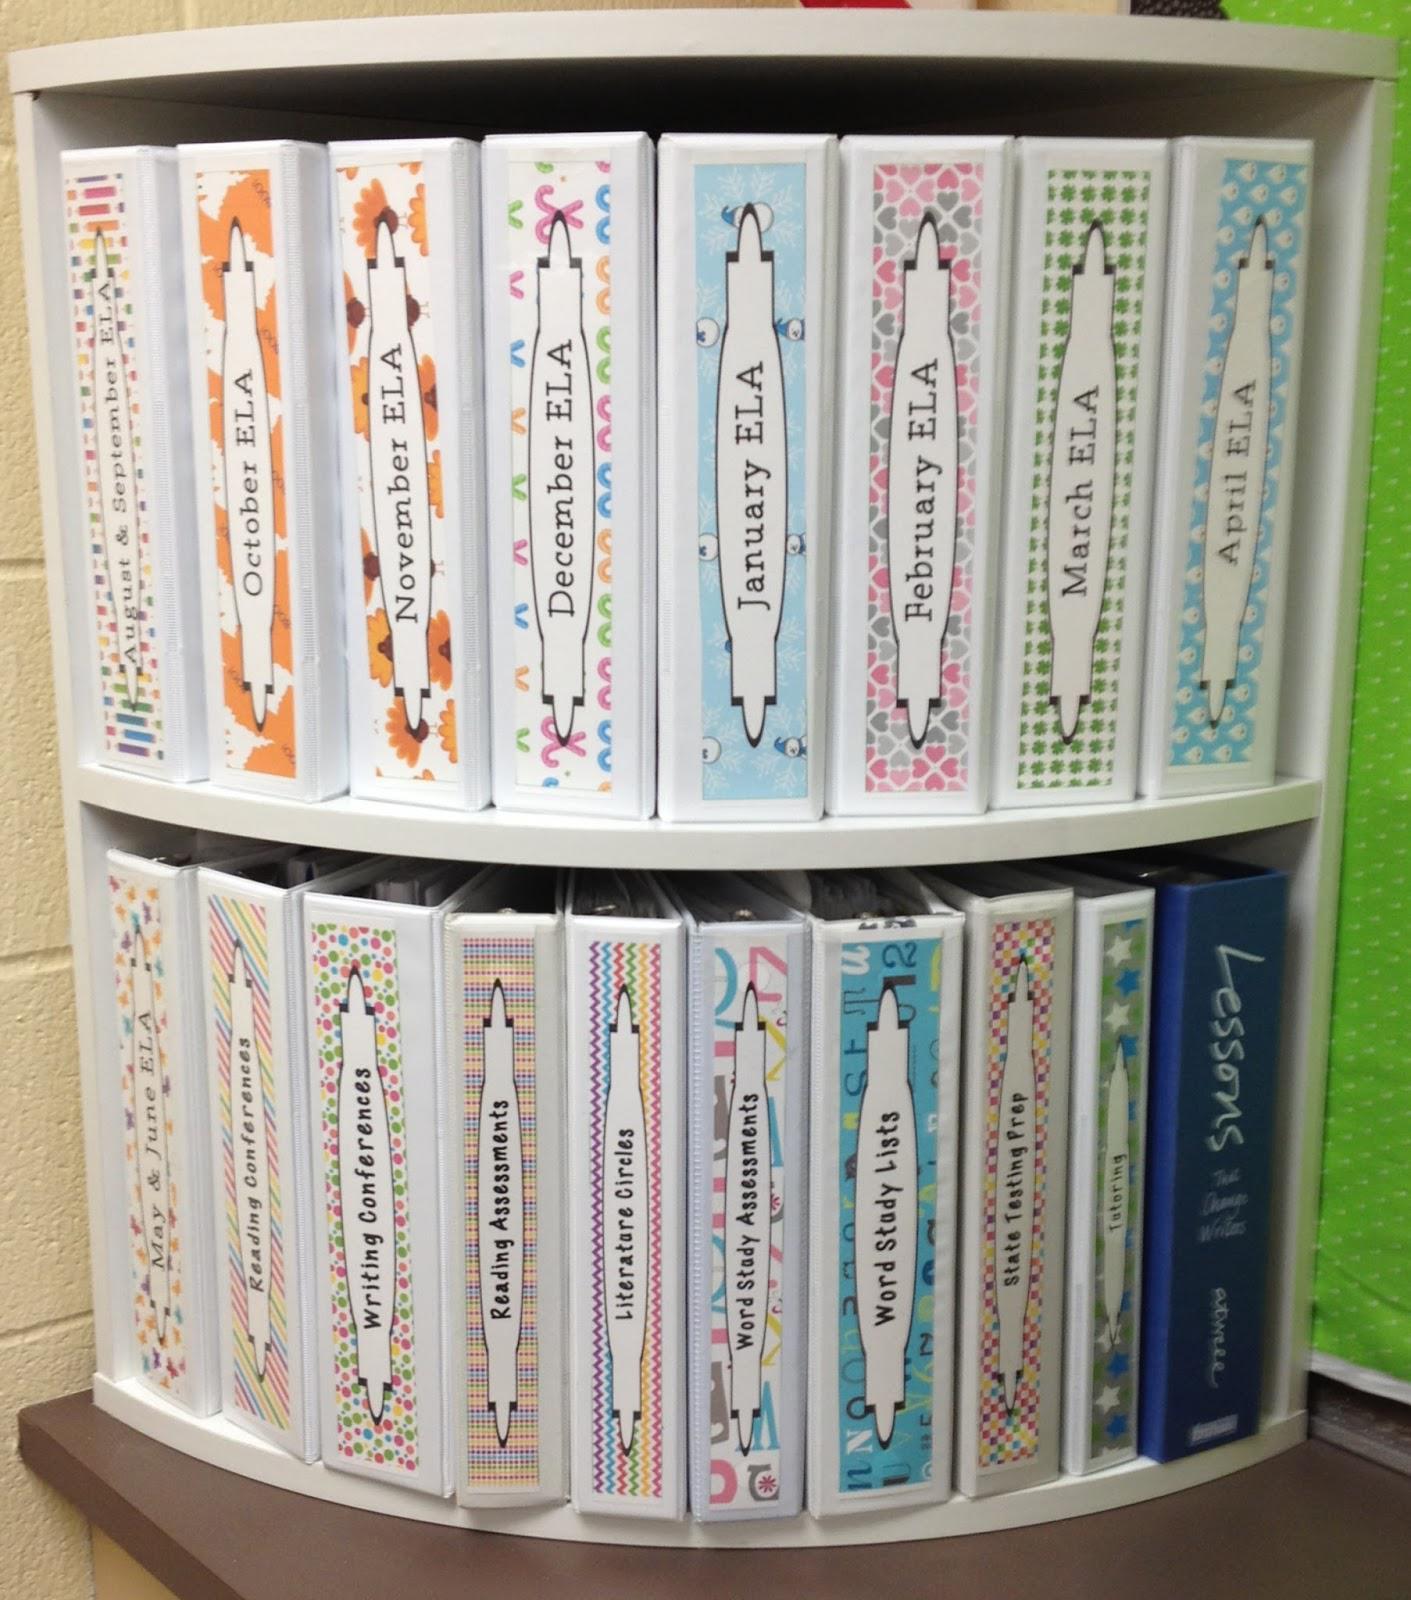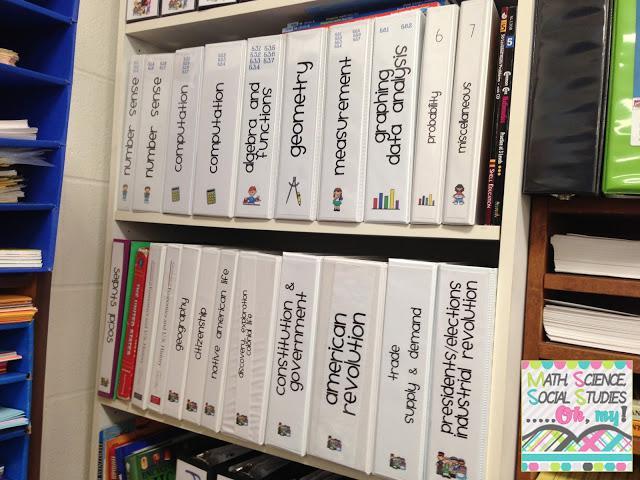The first image is the image on the left, the second image is the image on the right. For the images displayed, is the sentence "There is one open binder in the right image." factually correct? Answer yes or no. No. 